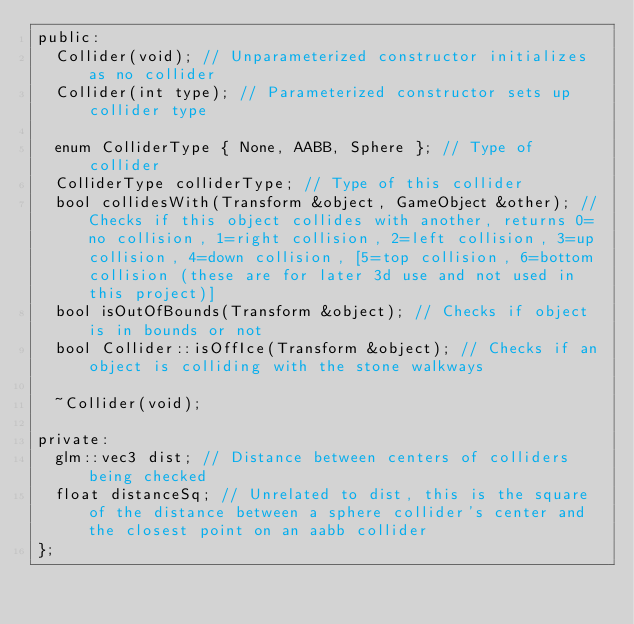<code> <loc_0><loc_0><loc_500><loc_500><_C_>public:
	Collider(void); // Unparameterized constructor initializes as no collider
	Collider(int type); // Parameterized constructor sets up collider type

	enum ColliderType { None, AABB, Sphere }; // Type of collider
	ColliderType colliderType; // Type of this collider
	bool collidesWith(Transform &object, GameObject &other); // Checks if this object collides with another, returns 0=no collision, 1=right collision, 2=left collision, 3=up collision, 4=down collision, [5=top collision, 6=bottom collision (these are for later 3d use and not used in this project)] 
	bool isOutOfBounds(Transform &object); // Checks if object is in bounds or not
	bool Collider::isOffIce(Transform &object); // Checks if an object is colliding with the stone walkways

	~Collider(void);

private:
	glm::vec3 dist; // Distance between centers of colliders being checked
	float distanceSq; // Unrelated to dist, this is the square of the distance between a sphere collider's center and the closest point on an aabb collider
};

</code> 